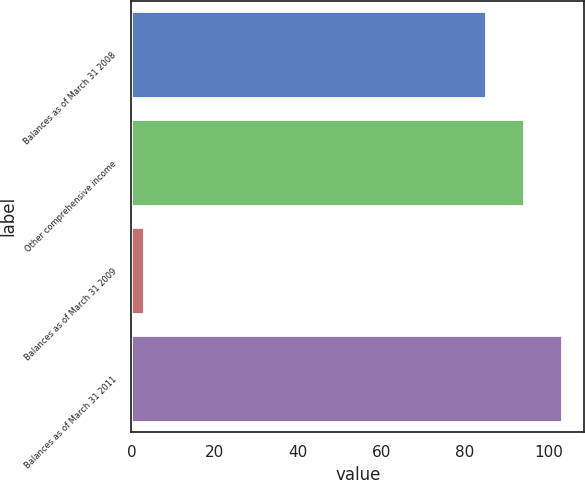<chart> <loc_0><loc_0><loc_500><loc_500><bar_chart><fcel>Balances as of March 31 2008<fcel>Other comprehensive income<fcel>Balances as of March 31 2009<fcel>Balances as of March 31 2011<nl><fcel>85<fcel>94.2<fcel>3<fcel>103.4<nl></chart> 